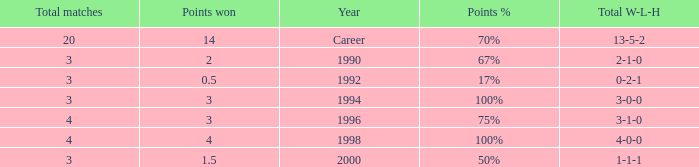Can you tell me the lowest Points won that has the Total matches of 4, and the Total W-L-H of 4-0-0? 4.0. 